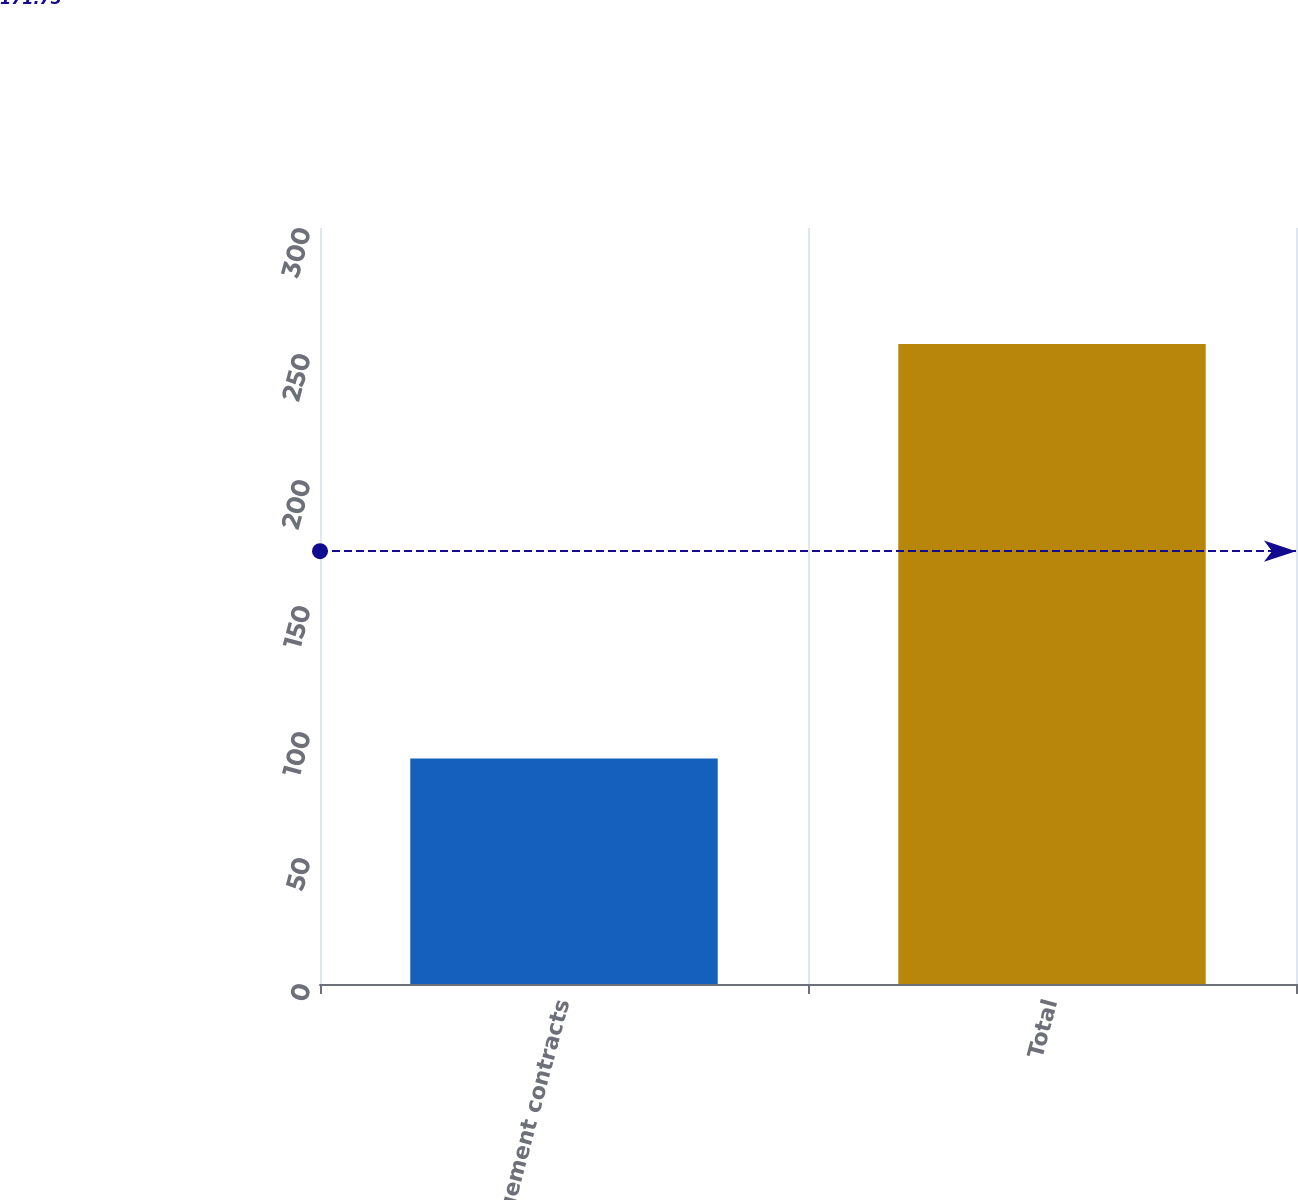Convert chart. <chart><loc_0><loc_0><loc_500><loc_500><bar_chart><fcel>Management contracts<fcel>Total<nl><fcel>89.5<fcel>254<nl></chart> 